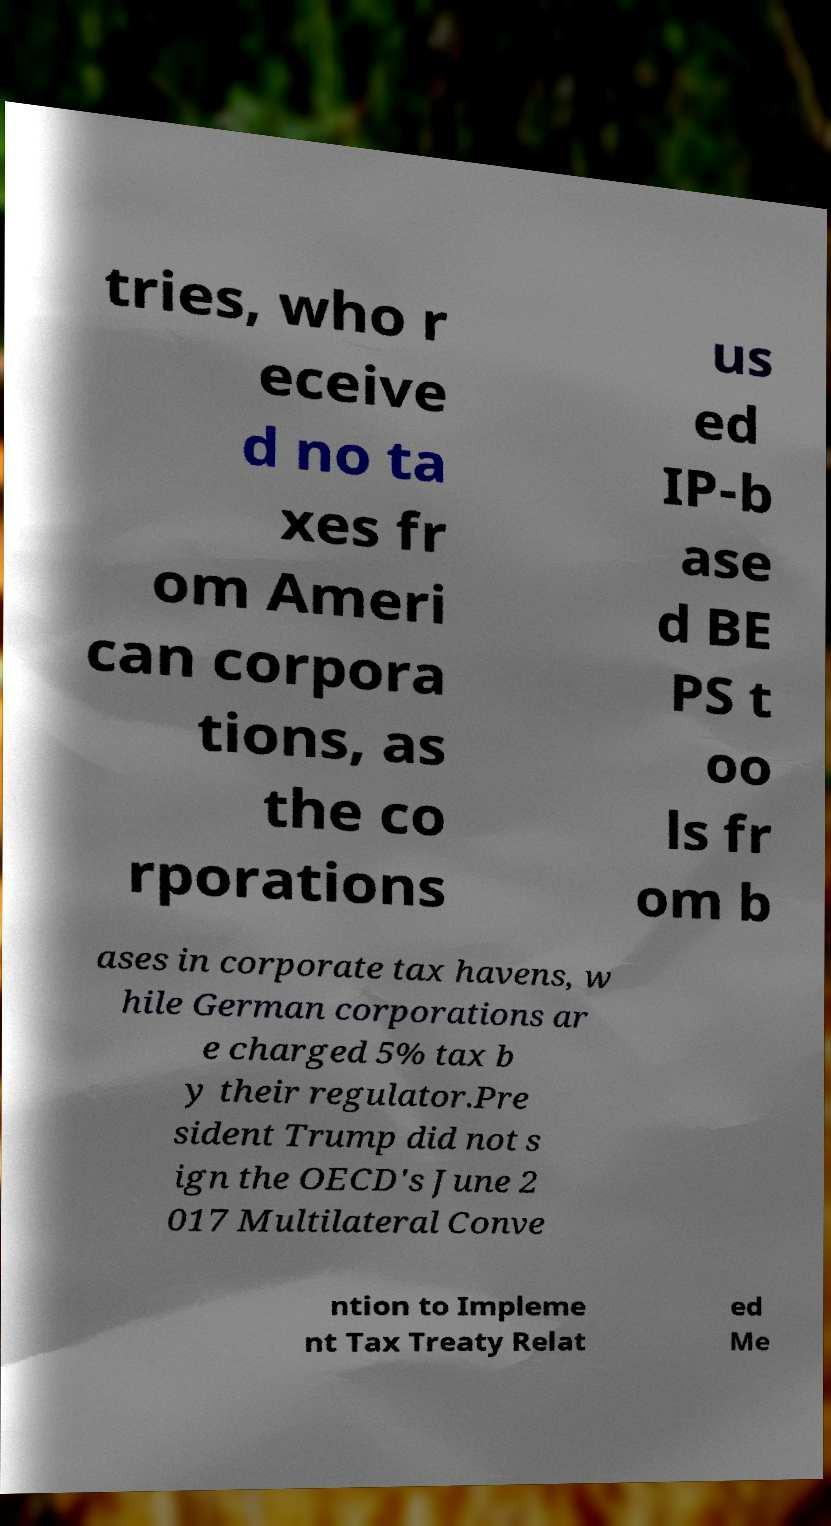Can you accurately transcribe the text from the provided image for me? tries, who r eceive d no ta xes fr om Ameri can corpora tions, as the co rporations us ed IP-b ase d BE PS t oo ls fr om b ases in corporate tax havens, w hile German corporations ar e charged 5% tax b y their regulator.Pre sident Trump did not s ign the OECD's June 2 017 Multilateral Conve ntion to Impleme nt Tax Treaty Relat ed Me 